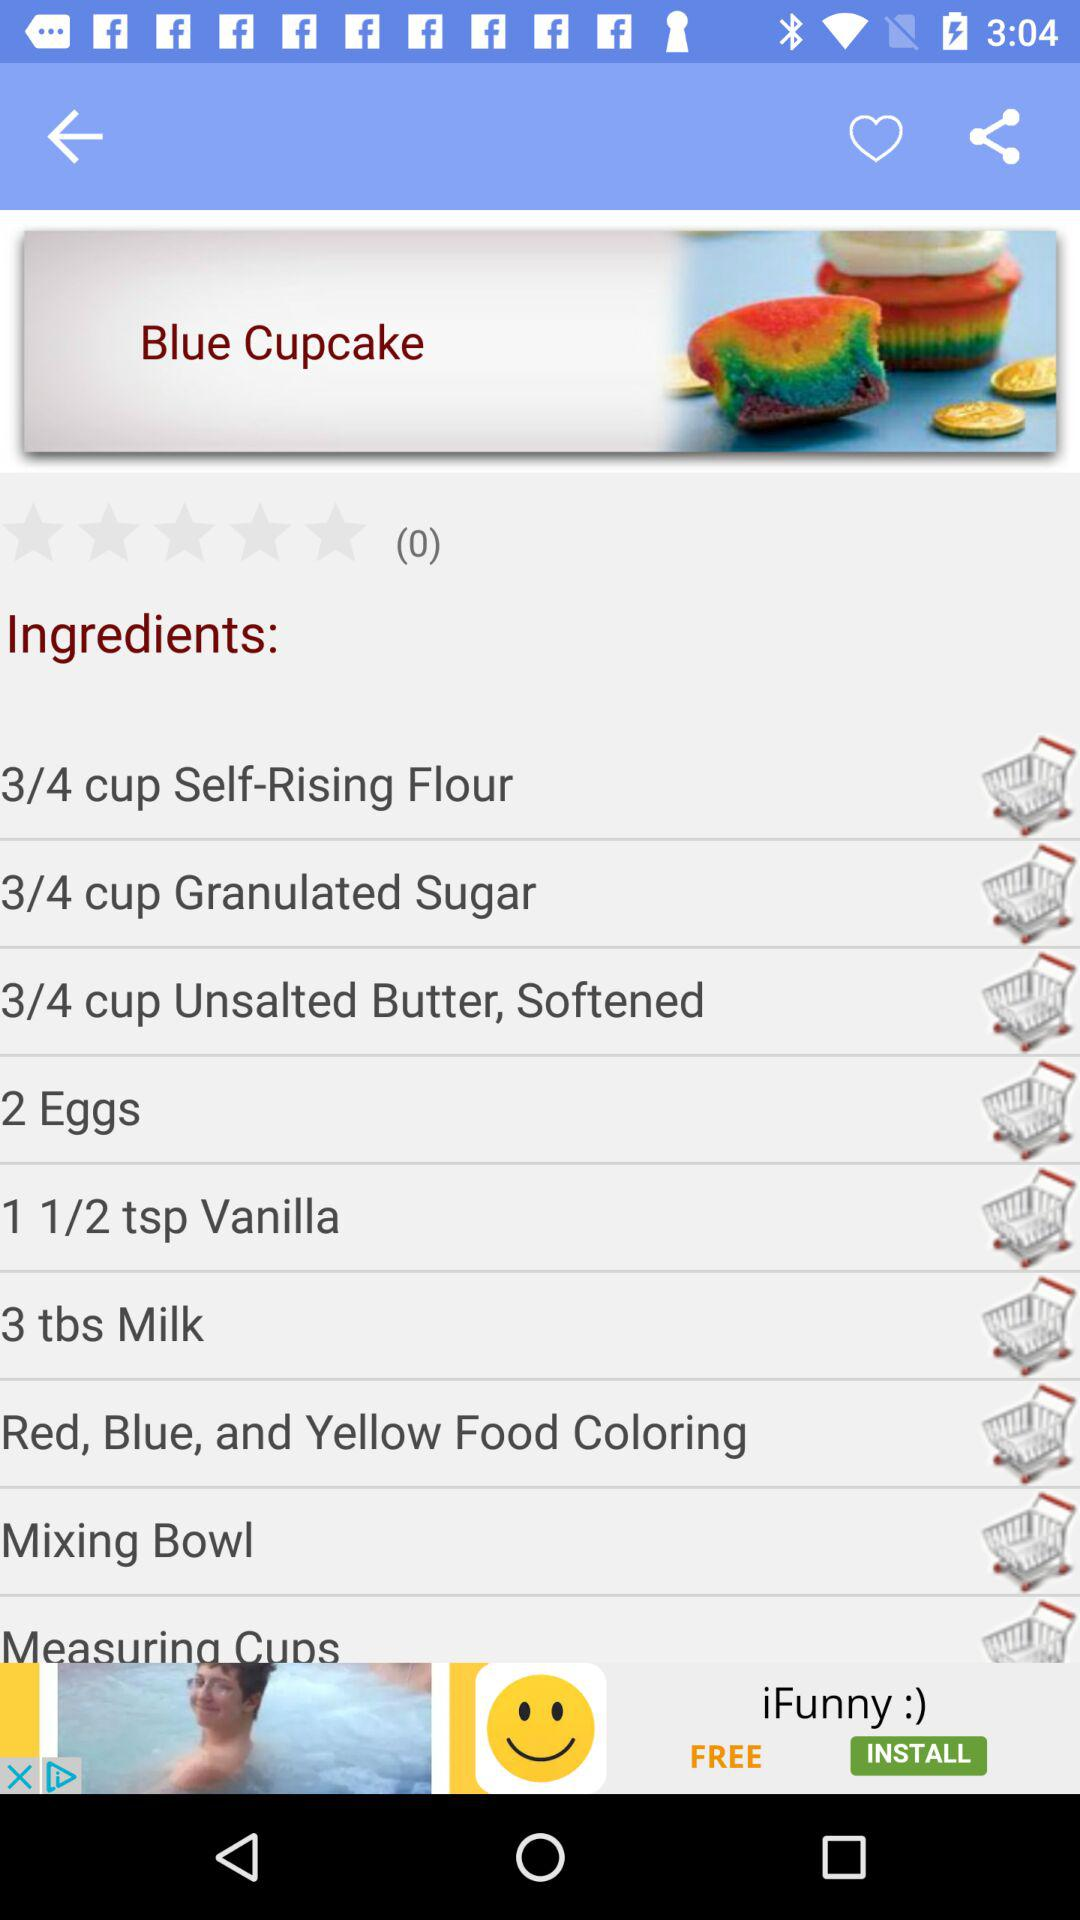What are the ingredients required to make the Blue Cupcake? The required ingredients are "3/4 cup Self-Rising Flour", "3/4 cup Granulated Sugar", "3/4 cup Unsalted Butter, Softened", "2 Eggs", "1 1/2 tsp Vanilla", "3 tbs Milk", "Red, Blue, and Yellow Food Coloring", "Mixing Bowl" and "Measuring Cups". 